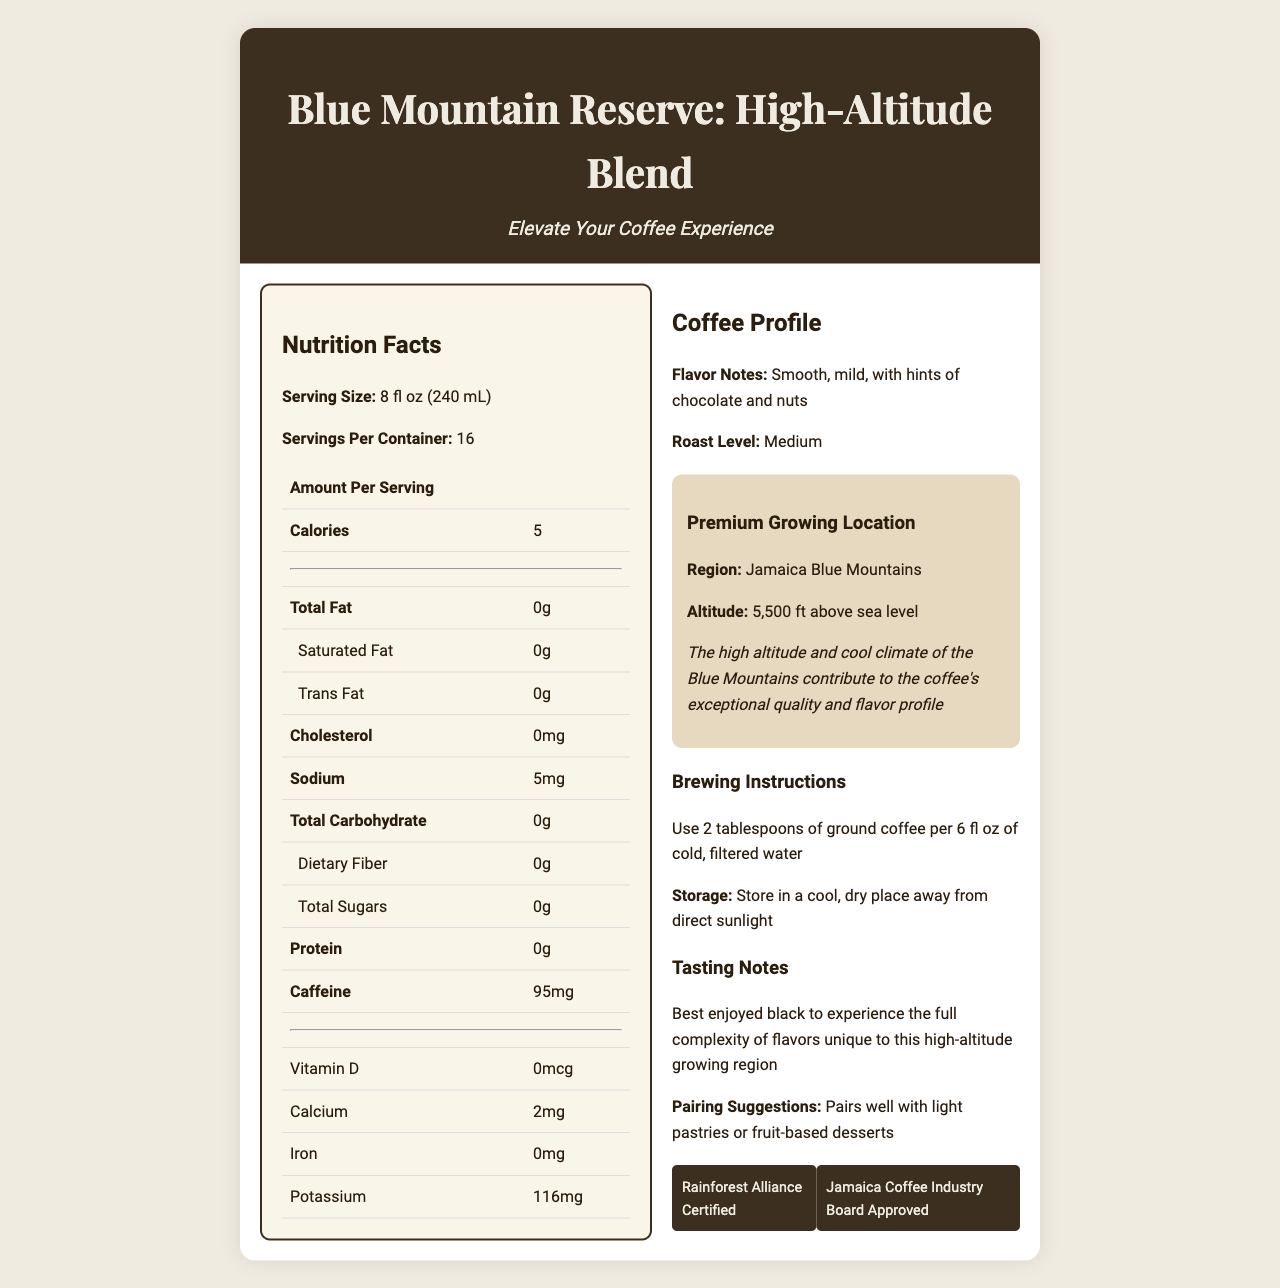what is the serving size? The serving size is listed under the Nutrition Facts section as "Serving Size: 8 fl oz (240 mL)."
Answer: 8 fl oz (240 mL) how many calories are there per serving? The Nutrition Facts section mentions "Calories" with a value of 5.
Answer: 5 what certifications does this coffee blend have? The certifications are listed under the Coffee Profile section, represented as badges.
Answer: Rainforest Alliance Certified, Jamaica Coffee Industry Board Approved where is this coffee grown? The growing region is detailed in the location-info section as "Region: Jamaica Blue Mountains."
Answer: Jamaica Blue Mountains how much caffeine is in each serving? The amount of caffeine per serving is listed as 95mg in the Nutrition Facts section.
Answer: 95mg what contributes to the coffee's exceptional quality and flavor profile? A. High-altitude growing B. Special brewing method C. Unique storage conditions D. Exotic flavoring The Coffee Profile section, specifically under location-info, highlights that the high altitude and cool climate of the Blue Mountains contribute to the coffee's exceptional quality and flavor profile.
Answer: A. High-altitude growing which of the following is NOT mentioned as a flavor note of this coffee blend? i. Chocolate ii. Caramel iii. Nuts The flavor notes are listed as "Smooth, mild, with hints of chocolate and nuts." Caramel is not mentioned.
Answer: ii. Caramel is this coffee blend best enjoyed with milk? The tasting notes section suggests, "Best enjoyed black to experience the full complexity of flavors unique to this high-altitude growing region," indicating it is best enjoyed without milk.
Answer: No describe the main characteristics highlighted about this coffee blend. The document highlights that the coffee is sourced from the Jamaica Blue Mountains and is grown at high altitudes, contributing to its exceptional quality. Flavor notes include hints of chocolate and nuts. It has certifications from the Rainforest Alliance and Jamaica Coffee Industry Board. The document includes brewing instructions, storage tips, and pairing suggestions.
Answer: The Blue Mountain Reserve: High-Altitude Blend is a specialty coffee sourced from the Jamaica Blue Mountains, known for its exceptional quality due to high-altitude growing conditions. It has a smooth and mild flavor with hints of chocolate and nuts, with 95mg of caffeine per serving. The coffee is Rainforest Alliance Certified and Jamaica Coffee Industry Board Approved. Best enjoyed black, it pairs well with light pastries or fruit-based desserts. which small-scale farmers contribute to the coffee's origin? The document mentions the coffee is sourced from small-scale farmers in the Jamaica Blue Mountains but does not provide specific details or names of the farmers.
Answer: Not enough information 